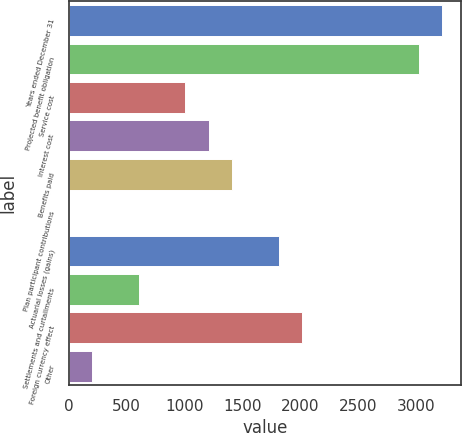Convert chart. <chart><loc_0><loc_0><loc_500><loc_500><bar_chart><fcel>Years ended December 31<fcel>Projected benefit obligation<fcel>Service cost<fcel>Interest cost<fcel>Benefits paid<fcel>Plan participant contributions<fcel>Actuarial losses (gains)<fcel>Settlements and curtailments<fcel>Foreign currency effect<fcel>Other<nl><fcel>3223.7<fcel>3022.25<fcel>1007.75<fcel>1209.2<fcel>1410.65<fcel>0.5<fcel>1813.55<fcel>604.85<fcel>2015<fcel>201.95<nl></chart> 